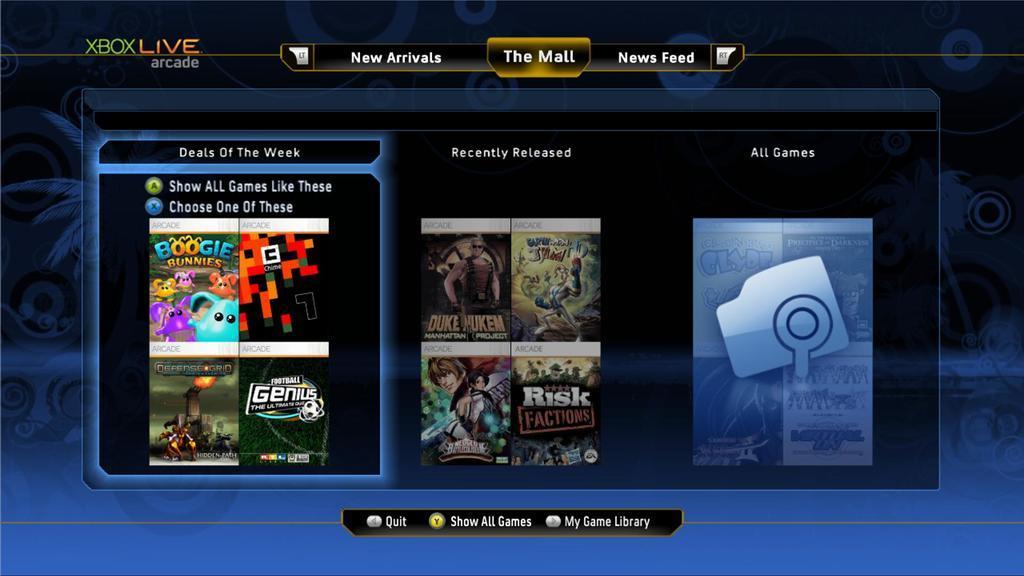Please provide a concise description of this image. This image consists of a screen with a few options of games and there is a text. 